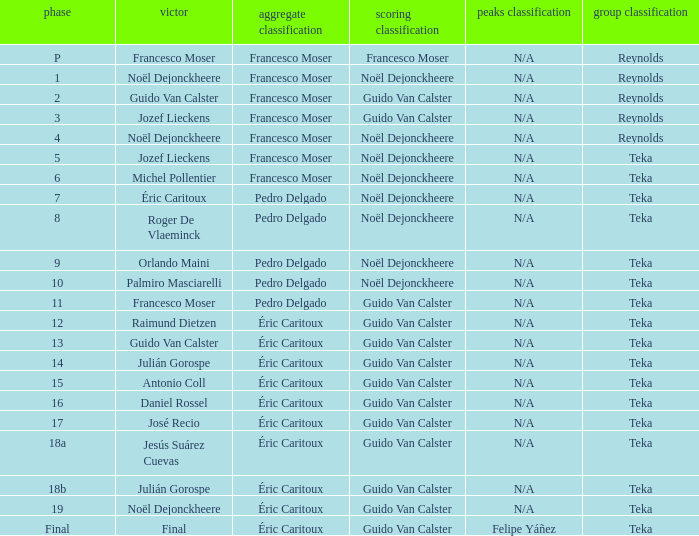Name the points classification for stage of 18b Guido Van Calster. 